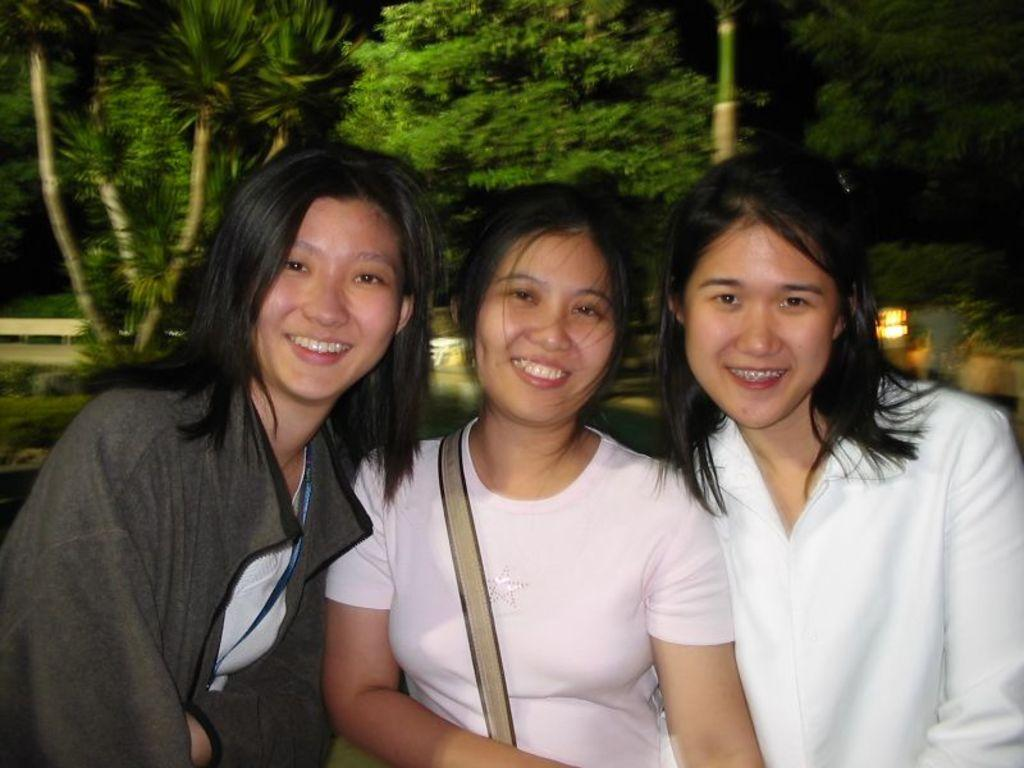How many people are in the image? There are three ladies in the image. What can be seen in the background of the image? There are trees and plants in the background of the image. Can you describe the lighting in the image? There is a light visible in the image. What type of agreement did the ladies reach in the image? There is no indication in the image that the ladies reached any agreement, as the image does not show any context or interaction between them. 